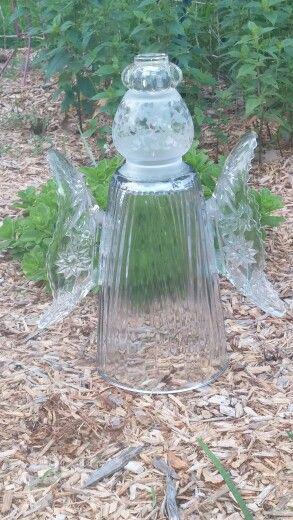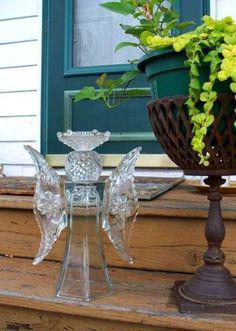The first image is the image on the left, the second image is the image on the right. Assess this claim about the two images: "In at least one image there is a glass angel looking vase that is touch leaves and dirt on the ground.". Correct or not? Answer yes or no. Yes. The first image is the image on the left, the second image is the image on the right. Evaluate the accuracy of this statement regarding the images: "One image features a tower of stacked glass vases and pedestals in various colors, and the stacked glassware does not combine to form a human-like figure.". Is it true? Answer yes or no. No. 